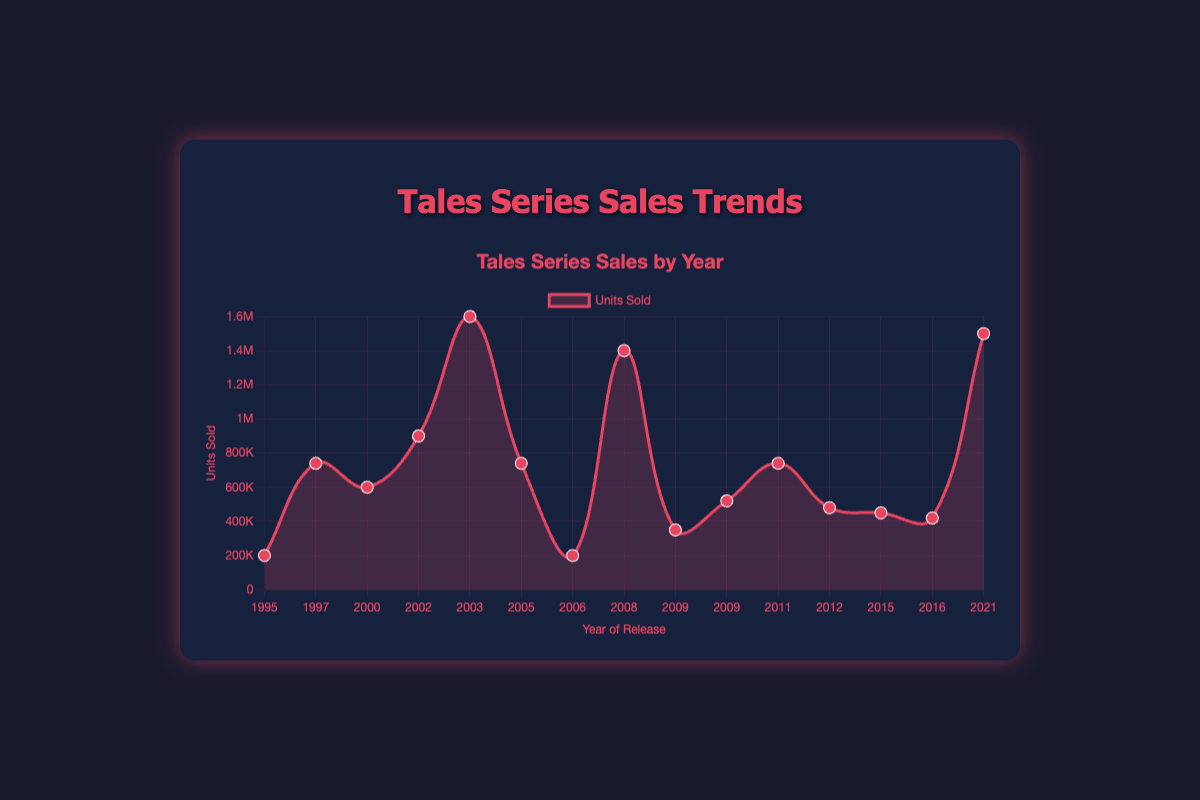What is the trend in the number of units sold from 1995 to 2021? To understand the trend, observe the overall direction of the lines and points. Although there are fluctuations, the general trend shows an increase, with notable peaks in 2003 ("Tales of Symphonia") and 2021 ("Tales of Arise").
Answer: Increasing Which game had the highest units sold, and in what year was it released? By examining the peak points, "Tales of Symphonia" in 2003 had the highest units sold with 1,600,000 units.
Answer: Tales of Symphonia, 2003 Compare the units sold for "Tales of Destiny" (1997) and "Tales of the Abyss" (2005). Which one sold more? Look at the data points for 1997 and 2005. "Tales of Destiny" (1997) sold 740,000 units, and "Tales of the Abyss" (2005) sold the same number of units.
Answer: Equal quantities What is the average number of units sold for the games released in 2009? There are two games in 2009: "Tales of Hearts" (350,000 units) and "Tales of Graces" (520,000 units). Sum their units sold (350,000 + 520,000 = 870,000) and divide by 2 to get the average (870,000 / 2 = 435,000).
Answer: 435,000 Compare the units sold for the games released consecutively in 2015 and 2016. Which year saw a higher sales figure? "Tales of Zestiria" in 2015 sold 450,000 units, while "Tales of Berseria" in 2016 sold 420,000 units. Thus, 2015 had higher sales.
Answer: 2015 Identify the game with the lowest units sold. How much did it sell, and in what year was it released? Check the lowest point on the chart. "Tales of Phantasia" (1995) and "Tales of the Tempest" (2006) both sold the lowest number of units, at 200,000 units each.
Answer: Tales of Phantasia and Tales of the Tempest, 200,000, 1995 and 2006 Calculate the total units sold for all games released before 2010. Add the units sold for all games released from 1995 to 2009. (200,000 + 740,000 + 600,000 + 900,000 + 1,600,000 + 740,000 + 200,000 + 1,400,000 + 350,000 + 520,000 = 7,250,000)
Answer: 7,250,000 Compare the sales trend for the games released in the 2000s vs the 2010s. Which decade had higher cumulative sales? Sum the units sold for the 2000s (600,000 + 900,000 + 1,600,000 + 740,000 + 200,000 + 1,400,000 + 350,000 + 520,000 = 6,310,000) and the 2010s (740,000 + 480,000 + 450,000 + 420,000 = 2,090,000). The 2000s had higher cumulative sales.
Answer: 2000s 